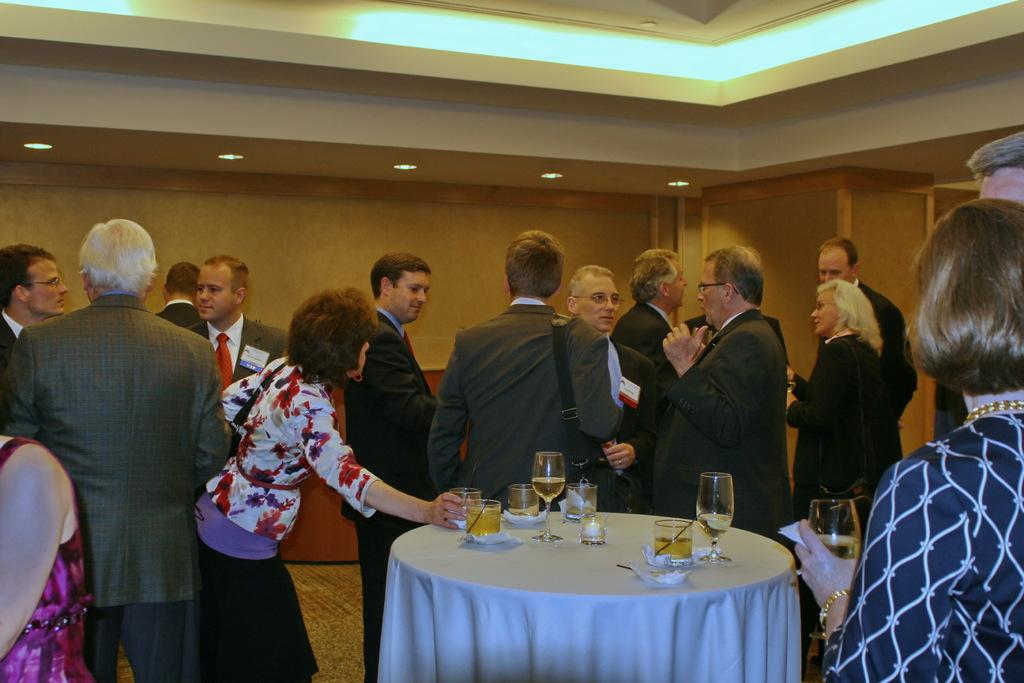What types of people are present in the room? There are men and women in the room. Can you describe any objects in the room? There are glasses on a table in the room. What type of lunch is being served in the room? There is no mention of lunch in the provided facts, so it cannot be determined from the image. 